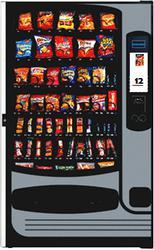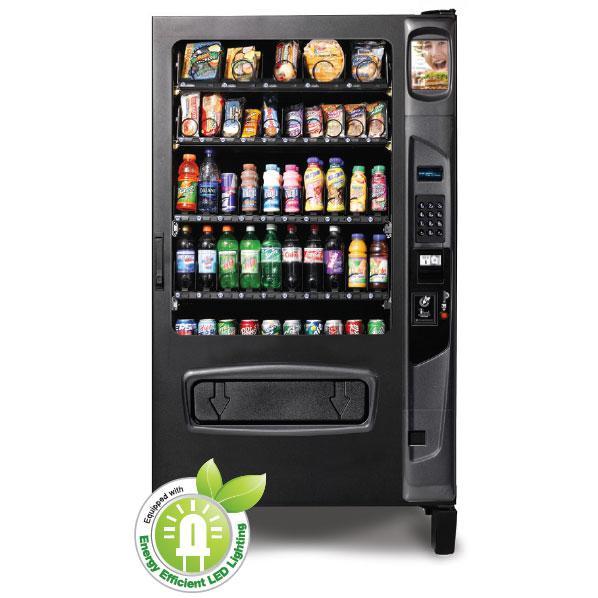The first image is the image on the left, the second image is the image on the right. For the images shown, is this caption "The dispensing port of the vending machine in the image on the right is outlined in gray." true? Answer yes or no. No. 